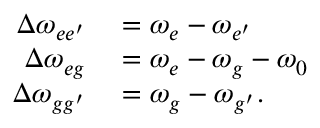<formula> <loc_0><loc_0><loc_500><loc_500>\begin{array} { r l } { \Delta \omega _ { { e e ^ { \prime } } } } & = \omega _ { e } - \omega _ { { e ^ { \prime } } } } \\ { \Delta \omega _ { e g } } & = \omega _ { e } - \omega _ { g } - \omega _ { 0 } } \\ { \Delta \omega _ { { g g ^ { \prime } } } } & = \omega _ { g } - \omega _ { { g ^ { \prime } } } . } \end{array}</formula> 